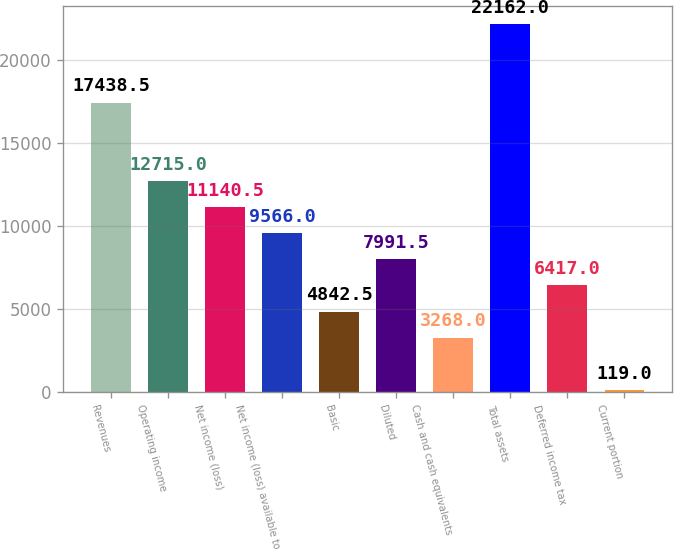<chart> <loc_0><loc_0><loc_500><loc_500><bar_chart><fcel>Revenues<fcel>Operating income<fcel>Net income (loss)<fcel>Net income (loss) available to<fcel>Basic<fcel>Diluted<fcel>Cash and cash equivalents<fcel>Total assets<fcel>Deferred income tax<fcel>Current portion<nl><fcel>17438.5<fcel>12715<fcel>11140.5<fcel>9566<fcel>4842.5<fcel>7991.5<fcel>3268<fcel>22162<fcel>6417<fcel>119<nl></chart> 